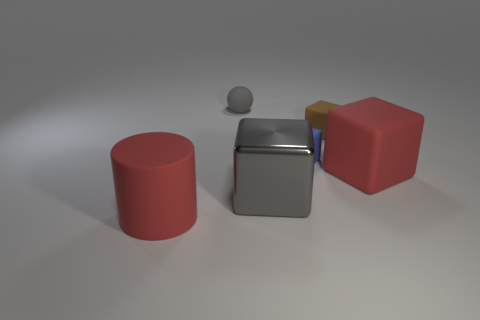Subtract all tiny blue rubber blocks. How many blocks are left? 3 Subtract all gray blocks. How many blocks are left? 3 Add 3 big metallic objects. How many objects exist? 9 Subtract all blocks. How many objects are left? 2 Add 3 gray objects. How many gray objects are left? 5 Add 6 spheres. How many spheres exist? 7 Subtract 0 red balls. How many objects are left? 6 Subtract all purple cubes. Subtract all blue cylinders. How many cubes are left? 4 Subtract all big red rubber cylinders. Subtract all tiny green matte spheres. How many objects are left? 5 